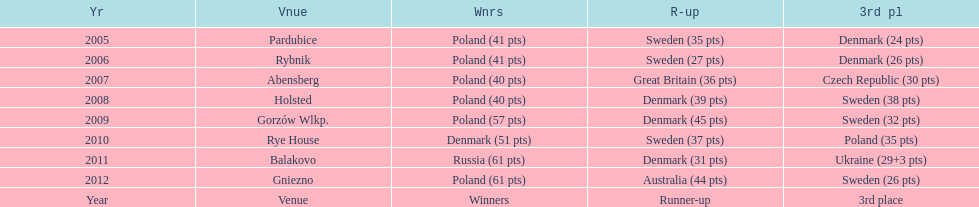After their first place win in 2009, how did poland place the next year at the speedway junior world championship? 3rd place. Could you help me parse every detail presented in this table? {'header': ['Yr', 'Vnue', 'Wnrs', 'R-up', '3rd pl'], 'rows': [['2005', 'Pardubice', 'Poland (41 pts)', 'Sweden (35 pts)', 'Denmark (24 pts)'], ['2006', 'Rybnik', 'Poland (41 pts)', 'Sweden (27 pts)', 'Denmark (26 pts)'], ['2007', 'Abensberg', 'Poland (40 pts)', 'Great Britain (36 pts)', 'Czech Republic (30 pts)'], ['2008', 'Holsted', 'Poland (40 pts)', 'Denmark (39 pts)', 'Sweden (38 pts)'], ['2009', 'Gorzów Wlkp.', 'Poland (57 pts)', 'Denmark (45 pts)', 'Sweden (32 pts)'], ['2010', 'Rye House', 'Denmark (51 pts)', 'Sweden (37 pts)', 'Poland (35 pts)'], ['2011', 'Balakovo', 'Russia (61 pts)', 'Denmark (31 pts)', 'Ukraine (29+3 pts)'], ['2012', 'Gniezno', 'Poland (61 pts)', 'Australia (44 pts)', 'Sweden (26 pts)'], ['Year', 'Venue', 'Winners', 'Runner-up', '3rd place']]} 